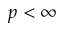<formula> <loc_0><loc_0><loc_500><loc_500>p < \infty</formula> 